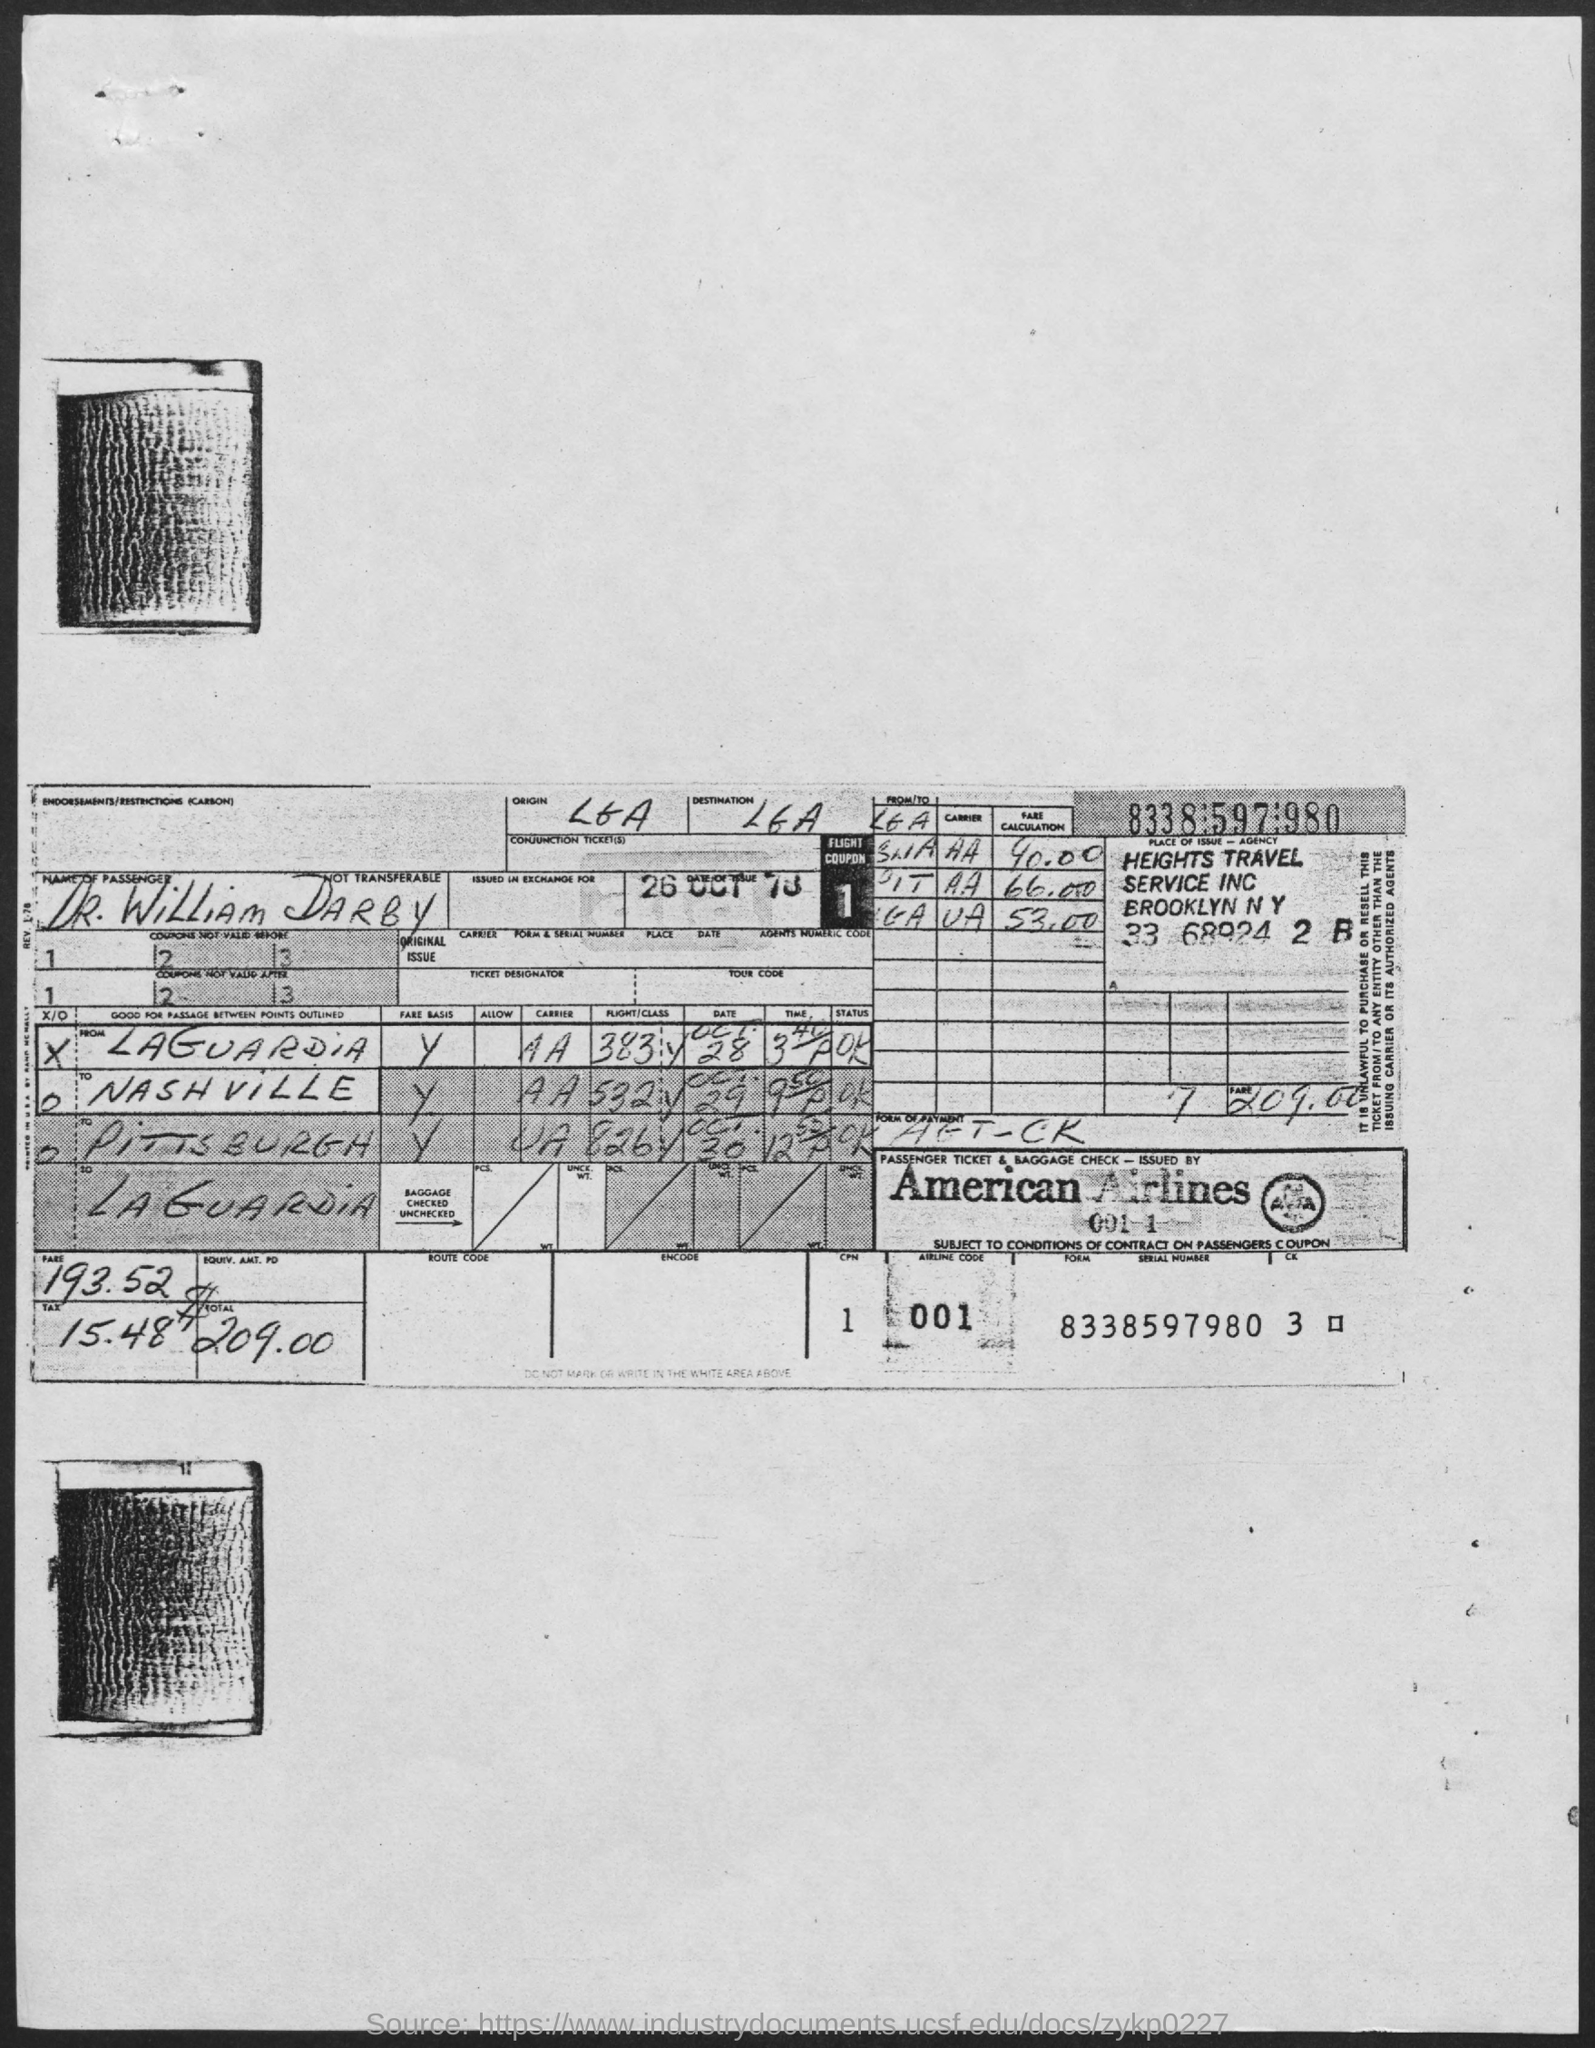Draw attention to some important aspects in this diagram. It is announced that the passenger's name is DR. WILLIAM DARBY. The passenger ticket and baggage check were issued by American Airlines. 